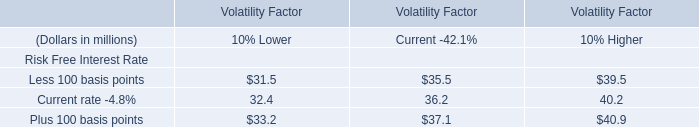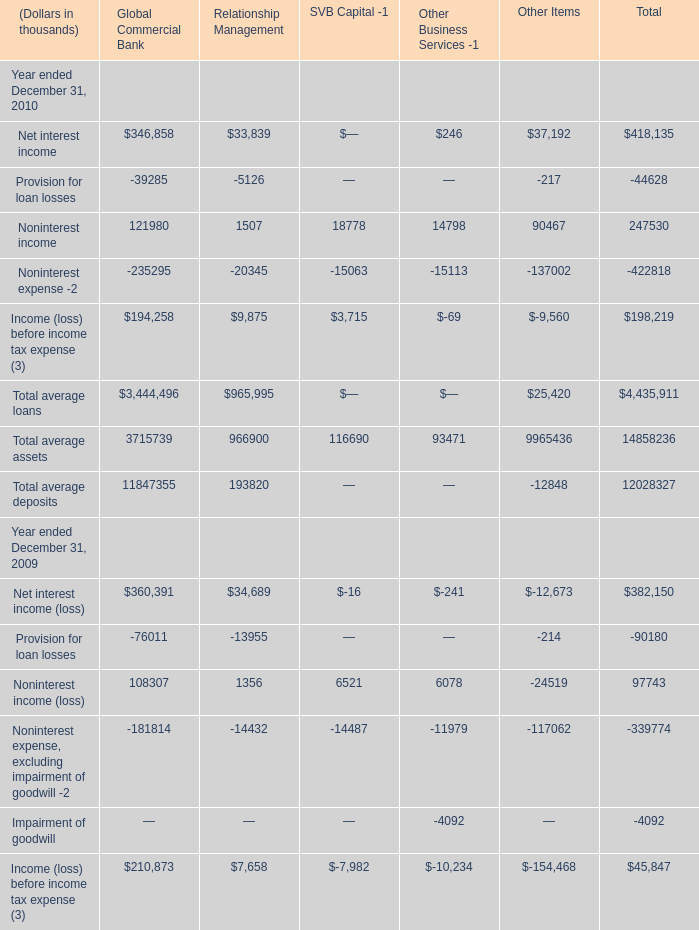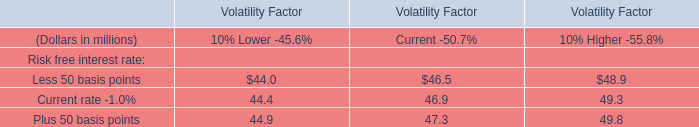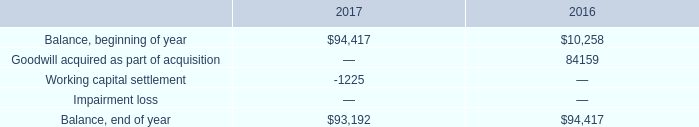Which year is Noninterest income for Total greater than 90000 ? 
Answer: 2009 2010. 